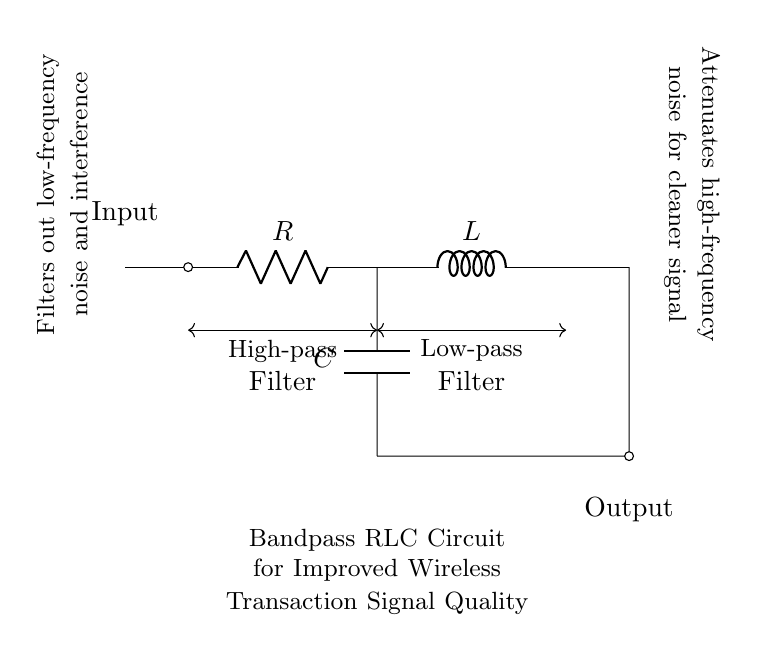What is the value of the resistor in the circuit? The circuit diagram identifies a resistor labeled as R. To determine its value, we would need additional data about the specific resistor used, as its resistance is not explicitly indicated in the diagram itself.
Answer: R What is the function of the capacitor in this circuit? The capacitor in a bandpass RLC circuit is primarily used to allow high-frequency signals to pass while blocking low-frequency signals. Its placement in parallel with the output in this configuration supports filtering unwanted low-frequency noise, thus enhancing the clarity of the signal.
Answer: High-pass filter What type of circuit is this? This is a bandpass RLC circuit. The components include a resistor, inductor, and capacitor arranged in series and parallel to create a bandpass filter response where only a specific range of frequencies is allowed to pass through.
Answer: Bandpass How does the inductor contribute to the circuit's function? The inductor resists changes in current and contributes to the low-pass filtering aspect of the circuit. By allowing low-frequency signals through while rejecting higher frequencies, it helps maintain a cleaner overall signal quality as part of the filtering process.
Answer: Low-pass filter What kind of noise does this circuit aim to filter out? This RLC circuit is designed to filter out low-frequency noise and interference, which can degrade the quality of wireless transactions in crowded environments where signal clarity is crucial.
Answer: Low-frequency noise How are the components connected in the circuit? The components are connected in a series-parallel arrangement: the resistor is in series with the inductor, which creates the series filter, while the capacitor is connected in parallel with the output. This configuration enables the desired filtering capabilities of the bandpass RLC circuit.
Answer: Series and parallel 